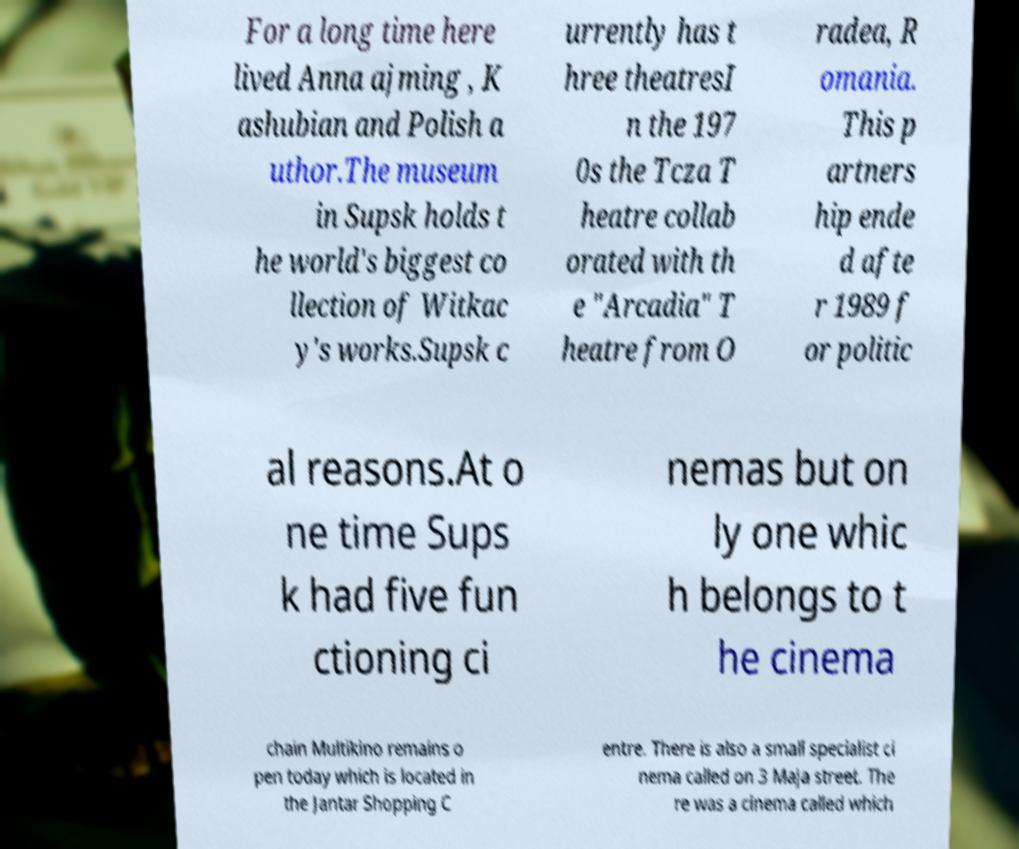Could you extract and type out the text from this image? For a long time here lived Anna ajming , K ashubian and Polish a uthor.The museum in Supsk holds t he world's biggest co llection of Witkac y's works.Supsk c urrently has t hree theatresI n the 197 0s the Tcza T heatre collab orated with th e "Arcadia" T heatre from O radea, R omania. This p artners hip ende d afte r 1989 f or politic al reasons.At o ne time Sups k had five fun ctioning ci nemas but on ly one whic h belongs to t he cinema chain Multikino remains o pen today which is located in the Jantar Shopping C entre. There is also a small specialist ci nema called on 3 Maja street. The re was a cinema called which 